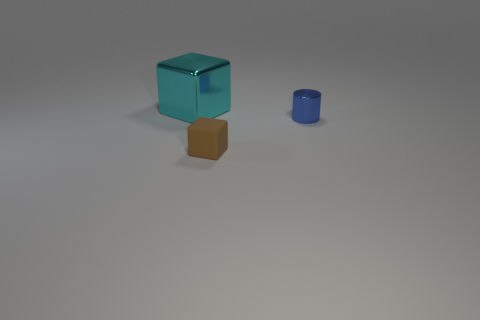Add 3 yellow matte spheres. How many objects exist? 6 Subtract all cylinders. How many objects are left? 2 Subtract 1 cyan cubes. How many objects are left? 2 Subtract all big cubes. Subtract all tiny things. How many objects are left? 0 Add 1 large objects. How many large objects are left? 2 Add 2 small yellow things. How many small yellow things exist? 2 